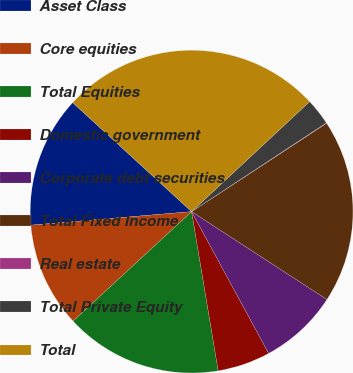<chart> <loc_0><loc_0><loc_500><loc_500><pie_chart><fcel>Asset Class<fcel>Core equities<fcel>Total Equities<fcel>Domestic government<fcel>Corporate debt securities<fcel>Total Fixed Income<fcel>Real estate<fcel>Total Private Equity<fcel>Total<nl><fcel>13.15%<fcel>10.53%<fcel>15.77%<fcel>5.29%<fcel>7.91%<fcel>18.39%<fcel>0.05%<fcel>2.67%<fcel>26.25%<nl></chart> 